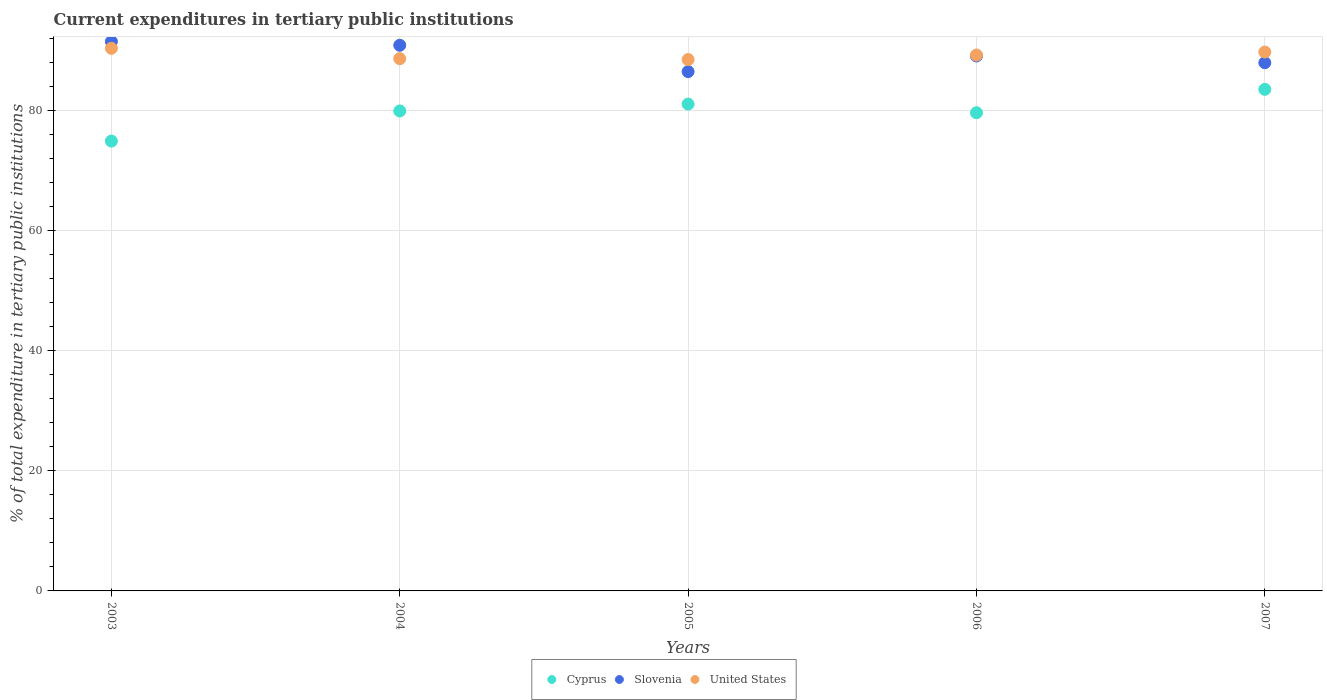What is the current expenditures in tertiary public institutions in Slovenia in 2005?
Offer a terse response. 86.42. Across all years, what is the maximum current expenditures in tertiary public institutions in Slovenia?
Provide a short and direct response. 91.42. Across all years, what is the minimum current expenditures in tertiary public institutions in United States?
Keep it short and to the point. 88.43. In which year was the current expenditures in tertiary public institutions in Cyprus minimum?
Provide a short and direct response. 2003. What is the total current expenditures in tertiary public institutions in United States in the graph?
Offer a terse response. 446.14. What is the difference between the current expenditures in tertiary public institutions in Cyprus in 2004 and that in 2006?
Make the answer very short. 0.3. What is the difference between the current expenditures in tertiary public institutions in Slovenia in 2003 and the current expenditures in tertiary public institutions in Cyprus in 2005?
Offer a very short reply. 10.41. What is the average current expenditures in tertiary public institutions in United States per year?
Ensure brevity in your answer.  89.23. In the year 2006, what is the difference between the current expenditures in tertiary public institutions in United States and current expenditures in tertiary public institutions in Cyprus?
Keep it short and to the point. 9.6. In how many years, is the current expenditures in tertiary public institutions in Slovenia greater than 52 %?
Your answer should be very brief. 5. What is the ratio of the current expenditures in tertiary public institutions in Slovenia in 2003 to that in 2004?
Offer a very short reply. 1.01. Is the current expenditures in tertiary public institutions in United States in 2004 less than that in 2006?
Give a very brief answer. Yes. Is the difference between the current expenditures in tertiary public institutions in United States in 2003 and 2007 greater than the difference between the current expenditures in tertiary public institutions in Cyprus in 2003 and 2007?
Provide a succinct answer. Yes. What is the difference between the highest and the second highest current expenditures in tertiary public institutions in Slovenia?
Keep it short and to the point. 0.62. What is the difference between the highest and the lowest current expenditures in tertiary public institutions in Cyprus?
Provide a short and direct response. 8.61. In how many years, is the current expenditures in tertiary public institutions in Slovenia greater than the average current expenditures in tertiary public institutions in Slovenia taken over all years?
Offer a very short reply. 2. Is the sum of the current expenditures in tertiary public institutions in Cyprus in 2005 and 2006 greater than the maximum current expenditures in tertiary public institutions in United States across all years?
Ensure brevity in your answer.  Yes. Does the current expenditures in tertiary public institutions in United States monotonically increase over the years?
Ensure brevity in your answer.  No. Is the current expenditures in tertiary public institutions in Slovenia strictly less than the current expenditures in tertiary public institutions in Cyprus over the years?
Your response must be concise. No. How many dotlines are there?
Give a very brief answer. 3. What is the difference between two consecutive major ticks on the Y-axis?
Ensure brevity in your answer.  20. Does the graph contain any zero values?
Your answer should be very brief. No. Does the graph contain grids?
Ensure brevity in your answer.  Yes. How many legend labels are there?
Provide a succinct answer. 3. How are the legend labels stacked?
Provide a succinct answer. Horizontal. What is the title of the graph?
Provide a short and direct response. Current expenditures in tertiary public institutions. Does "Kazakhstan" appear as one of the legend labels in the graph?
Your answer should be compact. No. What is the label or title of the X-axis?
Give a very brief answer. Years. What is the label or title of the Y-axis?
Give a very brief answer. % of total expenditure in tertiary public institutions. What is the % of total expenditure in tertiary public institutions in Cyprus in 2003?
Offer a terse response. 74.86. What is the % of total expenditure in tertiary public institutions of Slovenia in 2003?
Make the answer very short. 91.42. What is the % of total expenditure in tertiary public institutions in United States in 2003?
Your response must be concise. 90.3. What is the % of total expenditure in tertiary public institutions in Cyprus in 2004?
Your answer should be compact. 79.87. What is the % of total expenditure in tertiary public institutions of Slovenia in 2004?
Provide a succinct answer. 90.8. What is the % of total expenditure in tertiary public institutions in United States in 2004?
Provide a succinct answer. 88.57. What is the % of total expenditure in tertiary public institutions in Cyprus in 2005?
Your answer should be compact. 81.01. What is the % of total expenditure in tertiary public institutions in Slovenia in 2005?
Keep it short and to the point. 86.42. What is the % of total expenditure in tertiary public institutions of United States in 2005?
Give a very brief answer. 88.43. What is the % of total expenditure in tertiary public institutions of Cyprus in 2006?
Make the answer very short. 79.57. What is the % of total expenditure in tertiary public institutions in Slovenia in 2006?
Offer a terse response. 89.02. What is the % of total expenditure in tertiary public institutions of United States in 2006?
Ensure brevity in your answer.  89.17. What is the % of total expenditure in tertiary public institutions in Cyprus in 2007?
Offer a terse response. 83.47. What is the % of total expenditure in tertiary public institutions in Slovenia in 2007?
Your response must be concise. 87.9. What is the % of total expenditure in tertiary public institutions of United States in 2007?
Your answer should be very brief. 89.67. Across all years, what is the maximum % of total expenditure in tertiary public institutions of Cyprus?
Provide a short and direct response. 83.47. Across all years, what is the maximum % of total expenditure in tertiary public institutions of Slovenia?
Provide a short and direct response. 91.42. Across all years, what is the maximum % of total expenditure in tertiary public institutions of United States?
Make the answer very short. 90.3. Across all years, what is the minimum % of total expenditure in tertiary public institutions in Cyprus?
Offer a terse response. 74.86. Across all years, what is the minimum % of total expenditure in tertiary public institutions in Slovenia?
Offer a terse response. 86.42. Across all years, what is the minimum % of total expenditure in tertiary public institutions of United States?
Offer a terse response. 88.43. What is the total % of total expenditure in tertiary public institutions in Cyprus in the graph?
Make the answer very short. 398.78. What is the total % of total expenditure in tertiary public institutions in Slovenia in the graph?
Give a very brief answer. 445.56. What is the total % of total expenditure in tertiary public institutions in United States in the graph?
Your answer should be compact. 446.14. What is the difference between the % of total expenditure in tertiary public institutions of Cyprus in 2003 and that in 2004?
Make the answer very short. -5.01. What is the difference between the % of total expenditure in tertiary public institutions of Slovenia in 2003 and that in 2004?
Your response must be concise. 0.62. What is the difference between the % of total expenditure in tertiary public institutions in United States in 2003 and that in 2004?
Provide a succinct answer. 1.72. What is the difference between the % of total expenditure in tertiary public institutions of Cyprus in 2003 and that in 2005?
Your answer should be compact. -6.16. What is the difference between the % of total expenditure in tertiary public institutions of Slovenia in 2003 and that in 2005?
Keep it short and to the point. 5. What is the difference between the % of total expenditure in tertiary public institutions of United States in 2003 and that in 2005?
Give a very brief answer. 1.87. What is the difference between the % of total expenditure in tertiary public institutions of Cyprus in 2003 and that in 2006?
Offer a terse response. -4.72. What is the difference between the % of total expenditure in tertiary public institutions of Slovenia in 2003 and that in 2006?
Your response must be concise. 2.4. What is the difference between the % of total expenditure in tertiary public institutions of United States in 2003 and that in 2006?
Your response must be concise. 1.12. What is the difference between the % of total expenditure in tertiary public institutions of Cyprus in 2003 and that in 2007?
Provide a succinct answer. -8.61. What is the difference between the % of total expenditure in tertiary public institutions in Slovenia in 2003 and that in 2007?
Provide a succinct answer. 3.52. What is the difference between the % of total expenditure in tertiary public institutions of United States in 2003 and that in 2007?
Offer a very short reply. 0.62. What is the difference between the % of total expenditure in tertiary public institutions of Cyprus in 2004 and that in 2005?
Provide a short and direct response. -1.14. What is the difference between the % of total expenditure in tertiary public institutions in Slovenia in 2004 and that in 2005?
Your answer should be compact. 4.38. What is the difference between the % of total expenditure in tertiary public institutions in United States in 2004 and that in 2005?
Keep it short and to the point. 0.15. What is the difference between the % of total expenditure in tertiary public institutions in Cyprus in 2004 and that in 2006?
Provide a succinct answer. 0.3. What is the difference between the % of total expenditure in tertiary public institutions in Slovenia in 2004 and that in 2006?
Make the answer very short. 1.78. What is the difference between the % of total expenditure in tertiary public institutions in United States in 2004 and that in 2006?
Your response must be concise. -0.6. What is the difference between the % of total expenditure in tertiary public institutions of Cyprus in 2004 and that in 2007?
Provide a short and direct response. -3.6. What is the difference between the % of total expenditure in tertiary public institutions in Slovenia in 2004 and that in 2007?
Provide a succinct answer. 2.9. What is the difference between the % of total expenditure in tertiary public institutions of United States in 2004 and that in 2007?
Your answer should be very brief. -1.1. What is the difference between the % of total expenditure in tertiary public institutions of Cyprus in 2005 and that in 2006?
Ensure brevity in your answer.  1.44. What is the difference between the % of total expenditure in tertiary public institutions in Slovenia in 2005 and that in 2006?
Your answer should be compact. -2.6. What is the difference between the % of total expenditure in tertiary public institutions of United States in 2005 and that in 2006?
Your answer should be compact. -0.75. What is the difference between the % of total expenditure in tertiary public institutions of Cyprus in 2005 and that in 2007?
Your answer should be very brief. -2.45. What is the difference between the % of total expenditure in tertiary public institutions of Slovenia in 2005 and that in 2007?
Provide a succinct answer. -1.48. What is the difference between the % of total expenditure in tertiary public institutions of United States in 2005 and that in 2007?
Your answer should be very brief. -1.25. What is the difference between the % of total expenditure in tertiary public institutions in Cyprus in 2006 and that in 2007?
Your answer should be compact. -3.89. What is the difference between the % of total expenditure in tertiary public institutions in Slovenia in 2006 and that in 2007?
Make the answer very short. 1.12. What is the difference between the % of total expenditure in tertiary public institutions of United States in 2006 and that in 2007?
Your answer should be very brief. -0.5. What is the difference between the % of total expenditure in tertiary public institutions in Cyprus in 2003 and the % of total expenditure in tertiary public institutions in Slovenia in 2004?
Keep it short and to the point. -15.94. What is the difference between the % of total expenditure in tertiary public institutions in Cyprus in 2003 and the % of total expenditure in tertiary public institutions in United States in 2004?
Provide a short and direct response. -13.72. What is the difference between the % of total expenditure in tertiary public institutions in Slovenia in 2003 and the % of total expenditure in tertiary public institutions in United States in 2004?
Offer a very short reply. 2.85. What is the difference between the % of total expenditure in tertiary public institutions in Cyprus in 2003 and the % of total expenditure in tertiary public institutions in Slovenia in 2005?
Make the answer very short. -11.56. What is the difference between the % of total expenditure in tertiary public institutions in Cyprus in 2003 and the % of total expenditure in tertiary public institutions in United States in 2005?
Ensure brevity in your answer.  -13.57. What is the difference between the % of total expenditure in tertiary public institutions of Slovenia in 2003 and the % of total expenditure in tertiary public institutions of United States in 2005?
Make the answer very short. 2.99. What is the difference between the % of total expenditure in tertiary public institutions of Cyprus in 2003 and the % of total expenditure in tertiary public institutions of Slovenia in 2006?
Your response must be concise. -14.16. What is the difference between the % of total expenditure in tertiary public institutions in Cyprus in 2003 and the % of total expenditure in tertiary public institutions in United States in 2006?
Offer a terse response. -14.32. What is the difference between the % of total expenditure in tertiary public institutions of Slovenia in 2003 and the % of total expenditure in tertiary public institutions of United States in 2006?
Offer a terse response. 2.25. What is the difference between the % of total expenditure in tertiary public institutions in Cyprus in 2003 and the % of total expenditure in tertiary public institutions in Slovenia in 2007?
Ensure brevity in your answer.  -13.04. What is the difference between the % of total expenditure in tertiary public institutions of Cyprus in 2003 and the % of total expenditure in tertiary public institutions of United States in 2007?
Your answer should be very brief. -14.82. What is the difference between the % of total expenditure in tertiary public institutions of Slovenia in 2003 and the % of total expenditure in tertiary public institutions of United States in 2007?
Ensure brevity in your answer.  1.75. What is the difference between the % of total expenditure in tertiary public institutions of Cyprus in 2004 and the % of total expenditure in tertiary public institutions of Slovenia in 2005?
Your answer should be very brief. -6.55. What is the difference between the % of total expenditure in tertiary public institutions in Cyprus in 2004 and the % of total expenditure in tertiary public institutions in United States in 2005?
Provide a succinct answer. -8.56. What is the difference between the % of total expenditure in tertiary public institutions of Slovenia in 2004 and the % of total expenditure in tertiary public institutions of United States in 2005?
Your answer should be very brief. 2.38. What is the difference between the % of total expenditure in tertiary public institutions in Cyprus in 2004 and the % of total expenditure in tertiary public institutions in Slovenia in 2006?
Your response must be concise. -9.15. What is the difference between the % of total expenditure in tertiary public institutions in Cyprus in 2004 and the % of total expenditure in tertiary public institutions in United States in 2006?
Keep it short and to the point. -9.3. What is the difference between the % of total expenditure in tertiary public institutions in Slovenia in 2004 and the % of total expenditure in tertiary public institutions in United States in 2006?
Make the answer very short. 1.63. What is the difference between the % of total expenditure in tertiary public institutions of Cyprus in 2004 and the % of total expenditure in tertiary public institutions of Slovenia in 2007?
Make the answer very short. -8.03. What is the difference between the % of total expenditure in tertiary public institutions in Cyprus in 2004 and the % of total expenditure in tertiary public institutions in United States in 2007?
Offer a very short reply. -9.8. What is the difference between the % of total expenditure in tertiary public institutions in Slovenia in 2004 and the % of total expenditure in tertiary public institutions in United States in 2007?
Your response must be concise. 1.13. What is the difference between the % of total expenditure in tertiary public institutions in Cyprus in 2005 and the % of total expenditure in tertiary public institutions in Slovenia in 2006?
Ensure brevity in your answer.  -8.01. What is the difference between the % of total expenditure in tertiary public institutions of Cyprus in 2005 and the % of total expenditure in tertiary public institutions of United States in 2006?
Provide a succinct answer. -8.16. What is the difference between the % of total expenditure in tertiary public institutions in Slovenia in 2005 and the % of total expenditure in tertiary public institutions in United States in 2006?
Your answer should be very brief. -2.75. What is the difference between the % of total expenditure in tertiary public institutions in Cyprus in 2005 and the % of total expenditure in tertiary public institutions in Slovenia in 2007?
Offer a terse response. -6.89. What is the difference between the % of total expenditure in tertiary public institutions in Cyprus in 2005 and the % of total expenditure in tertiary public institutions in United States in 2007?
Offer a very short reply. -8.66. What is the difference between the % of total expenditure in tertiary public institutions in Slovenia in 2005 and the % of total expenditure in tertiary public institutions in United States in 2007?
Make the answer very short. -3.25. What is the difference between the % of total expenditure in tertiary public institutions in Cyprus in 2006 and the % of total expenditure in tertiary public institutions in Slovenia in 2007?
Provide a short and direct response. -8.33. What is the difference between the % of total expenditure in tertiary public institutions in Cyprus in 2006 and the % of total expenditure in tertiary public institutions in United States in 2007?
Give a very brief answer. -10.1. What is the difference between the % of total expenditure in tertiary public institutions of Slovenia in 2006 and the % of total expenditure in tertiary public institutions of United States in 2007?
Provide a short and direct response. -0.65. What is the average % of total expenditure in tertiary public institutions in Cyprus per year?
Your response must be concise. 79.76. What is the average % of total expenditure in tertiary public institutions of Slovenia per year?
Offer a terse response. 89.11. What is the average % of total expenditure in tertiary public institutions in United States per year?
Offer a very short reply. 89.23. In the year 2003, what is the difference between the % of total expenditure in tertiary public institutions in Cyprus and % of total expenditure in tertiary public institutions in Slovenia?
Ensure brevity in your answer.  -16.56. In the year 2003, what is the difference between the % of total expenditure in tertiary public institutions of Cyprus and % of total expenditure in tertiary public institutions of United States?
Offer a terse response. -15.44. In the year 2003, what is the difference between the % of total expenditure in tertiary public institutions of Slovenia and % of total expenditure in tertiary public institutions of United States?
Offer a terse response. 1.12. In the year 2004, what is the difference between the % of total expenditure in tertiary public institutions in Cyprus and % of total expenditure in tertiary public institutions in Slovenia?
Offer a terse response. -10.93. In the year 2004, what is the difference between the % of total expenditure in tertiary public institutions of Cyprus and % of total expenditure in tertiary public institutions of United States?
Offer a terse response. -8.7. In the year 2004, what is the difference between the % of total expenditure in tertiary public institutions of Slovenia and % of total expenditure in tertiary public institutions of United States?
Keep it short and to the point. 2.23. In the year 2005, what is the difference between the % of total expenditure in tertiary public institutions of Cyprus and % of total expenditure in tertiary public institutions of Slovenia?
Your response must be concise. -5.41. In the year 2005, what is the difference between the % of total expenditure in tertiary public institutions in Cyprus and % of total expenditure in tertiary public institutions in United States?
Keep it short and to the point. -7.41. In the year 2005, what is the difference between the % of total expenditure in tertiary public institutions of Slovenia and % of total expenditure in tertiary public institutions of United States?
Make the answer very short. -2.01. In the year 2006, what is the difference between the % of total expenditure in tertiary public institutions in Cyprus and % of total expenditure in tertiary public institutions in Slovenia?
Ensure brevity in your answer.  -9.45. In the year 2006, what is the difference between the % of total expenditure in tertiary public institutions of Cyprus and % of total expenditure in tertiary public institutions of United States?
Ensure brevity in your answer.  -9.6. In the year 2006, what is the difference between the % of total expenditure in tertiary public institutions of Slovenia and % of total expenditure in tertiary public institutions of United States?
Ensure brevity in your answer.  -0.15. In the year 2007, what is the difference between the % of total expenditure in tertiary public institutions in Cyprus and % of total expenditure in tertiary public institutions in Slovenia?
Your answer should be very brief. -4.43. In the year 2007, what is the difference between the % of total expenditure in tertiary public institutions of Cyprus and % of total expenditure in tertiary public institutions of United States?
Offer a very short reply. -6.21. In the year 2007, what is the difference between the % of total expenditure in tertiary public institutions in Slovenia and % of total expenditure in tertiary public institutions in United States?
Make the answer very short. -1.77. What is the ratio of the % of total expenditure in tertiary public institutions of Cyprus in 2003 to that in 2004?
Your answer should be compact. 0.94. What is the ratio of the % of total expenditure in tertiary public institutions of Slovenia in 2003 to that in 2004?
Provide a succinct answer. 1.01. What is the ratio of the % of total expenditure in tertiary public institutions in United States in 2003 to that in 2004?
Offer a terse response. 1.02. What is the ratio of the % of total expenditure in tertiary public institutions of Cyprus in 2003 to that in 2005?
Make the answer very short. 0.92. What is the ratio of the % of total expenditure in tertiary public institutions of Slovenia in 2003 to that in 2005?
Offer a very short reply. 1.06. What is the ratio of the % of total expenditure in tertiary public institutions of United States in 2003 to that in 2005?
Keep it short and to the point. 1.02. What is the ratio of the % of total expenditure in tertiary public institutions of Cyprus in 2003 to that in 2006?
Provide a succinct answer. 0.94. What is the ratio of the % of total expenditure in tertiary public institutions in Slovenia in 2003 to that in 2006?
Offer a terse response. 1.03. What is the ratio of the % of total expenditure in tertiary public institutions in United States in 2003 to that in 2006?
Your response must be concise. 1.01. What is the ratio of the % of total expenditure in tertiary public institutions of Cyprus in 2003 to that in 2007?
Offer a terse response. 0.9. What is the ratio of the % of total expenditure in tertiary public institutions in Slovenia in 2003 to that in 2007?
Provide a short and direct response. 1.04. What is the ratio of the % of total expenditure in tertiary public institutions in United States in 2003 to that in 2007?
Ensure brevity in your answer.  1.01. What is the ratio of the % of total expenditure in tertiary public institutions in Cyprus in 2004 to that in 2005?
Provide a short and direct response. 0.99. What is the ratio of the % of total expenditure in tertiary public institutions in Slovenia in 2004 to that in 2005?
Ensure brevity in your answer.  1.05. What is the ratio of the % of total expenditure in tertiary public institutions in United States in 2004 to that in 2005?
Ensure brevity in your answer.  1. What is the ratio of the % of total expenditure in tertiary public institutions of Cyprus in 2004 to that in 2006?
Give a very brief answer. 1. What is the ratio of the % of total expenditure in tertiary public institutions in Slovenia in 2004 to that in 2006?
Your answer should be compact. 1.02. What is the ratio of the % of total expenditure in tertiary public institutions of Cyprus in 2004 to that in 2007?
Ensure brevity in your answer.  0.96. What is the ratio of the % of total expenditure in tertiary public institutions in Slovenia in 2004 to that in 2007?
Your answer should be compact. 1.03. What is the ratio of the % of total expenditure in tertiary public institutions in United States in 2004 to that in 2007?
Your answer should be very brief. 0.99. What is the ratio of the % of total expenditure in tertiary public institutions of Cyprus in 2005 to that in 2006?
Offer a very short reply. 1.02. What is the ratio of the % of total expenditure in tertiary public institutions of Slovenia in 2005 to that in 2006?
Keep it short and to the point. 0.97. What is the ratio of the % of total expenditure in tertiary public institutions in Cyprus in 2005 to that in 2007?
Provide a succinct answer. 0.97. What is the ratio of the % of total expenditure in tertiary public institutions in Slovenia in 2005 to that in 2007?
Provide a succinct answer. 0.98. What is the ratio of the % of total expenditure in tertiary public institutions in United States in 2005 to that in 2007?
Provide a short and direct response. 0.99. What is the ratio of the % of total expenditure in tertiary public institutions of Cyprus in 2006 to that in 2007?
Provide a short and direct response. 0.95. What is the ratio of the % of total expenditure in tertiary public institutions of Slovenia in 2006 to that in 2007?
Your answer should be very brief. 1.01. What is the difference between the highest and the second highest % of total expenditure in tertiary public institutions of Cyprus?
Give a very brief answer. 2.45. What is the difference between the highest and the second highest % of total expenditure in tertiary public institutions of Slovenia?
Keep it short and to the point. 0.62. What is the difference between the highest and the second highest % of total expenditure in tertiary public institutions in United States?
Your response must be concise. 0.62. What is the difference between the highest and the lowest % of total expenditure in tertiary public institutions of Cyprus?
Ensure brevity in your answer.  8.61. What is the difference between the highest and the lowest % of total expenditure in tertiary public institutions of Slovenia?
Ensure brevity in your answer.  5. What is the difference between the highest and the lowest % of total expenditure in tertiary public institutions of United States?
Your answer should be compact. 1.87. 